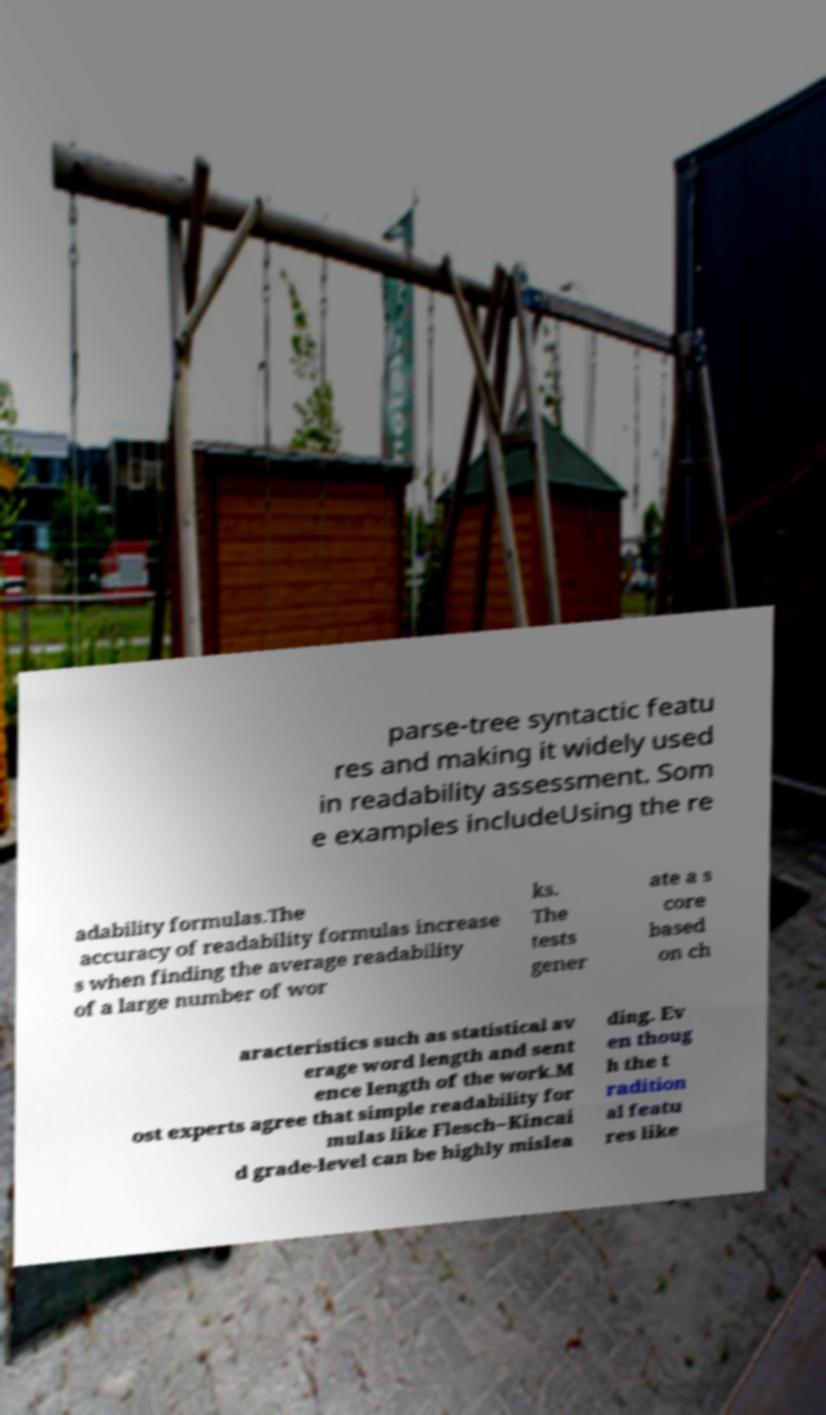I need the written content from this picture converted into text. Can you do that? parse-tree syntactic featu res and making it widely used in readability assessment. Som e examples includeUsing the re adability formulas.The accuracy of readability formulas increase s when finding the average readability of a large number of wor ks. The tests gener ate a s core based on ch aracteristics such as statistical av erage word length and sent ence length of the work.M ost experts agree that simple readability for mulas like Flesch–Kincai d grade-level can be highly mislea ding. Ev en thoug h the t radition al featu res like 